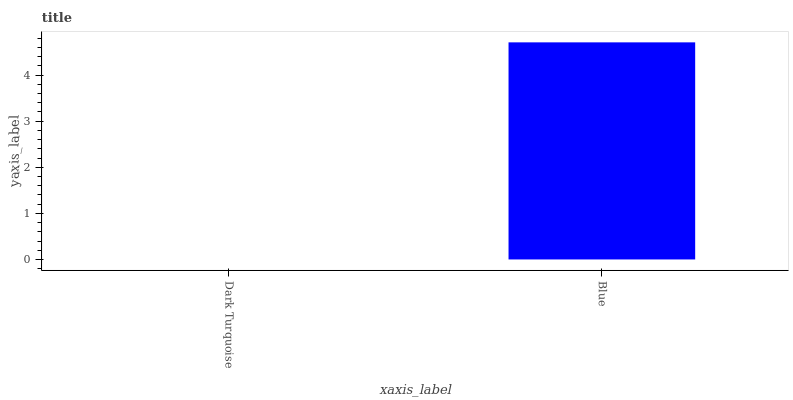Is Dark Turquoise the minimum?
Answer yes or no. Yes. Is Blue the maximum?
Answer yes or no. Yes. Is Blue the minimum?
Answer yes or no. No. Is Blue greater than Dark Turquoise?
Answer yes or no. Yes. Is Dark Turquoise less than Blue?
Answer yes or no. Yes. Is Dark Turquoise greater than Blue?
Answer yes or no. No. Is Blue less than Dark Turquoise?
Answer yes or no. No. Is Blue the high median?
Answer yes or no. Yes. Is Dark Turquoise the low median?
Answer yes or no. Yes. Is Dark Turquoise the high median?
Answer yes or no. No. Is Blue the low median?
Answer yes or no. No. 